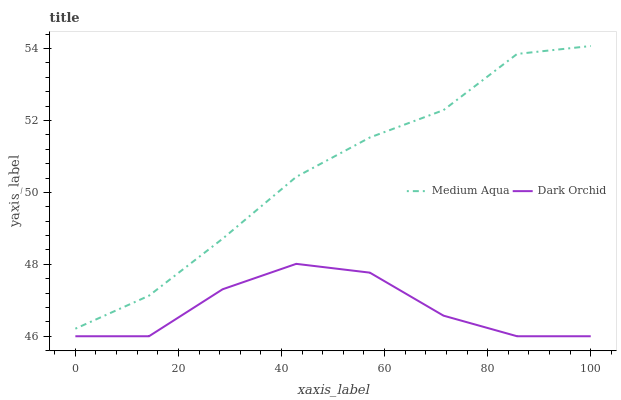Does Dark Orchid have the minimum area under the curve?
Answer yes or no. Yes. Does Medium Aqua have the maximum area under the curve?
Answer yes or no. Yes. Does Dark Orchid have the maximum area under the curve?
Answer yes or no. No. Is Medium Aqua the smoothest?
Answer yes or no. Yes. Is Dark Orchid the roughest?
Answer yes or no. Yes. Is Dark Orchid the smoothest?
Answer yes or no. No. Does Dark Orchid have the lowest value?
Answer yes or no. Yes. Does Medium Aqua have the highest value?
Answer yes or no. Yes. Does Dark Orchid have the highest value?
Answer yes or no. No. Is Dark Orchid less than Medium Aqua?
Answer yes or no. Yes. Is Medium Aqua greater than Dark Orchid?
Answer yes or no. Yes. Does Dark Orchid intersect Medium Aqua?
Answer yes or no. No. 